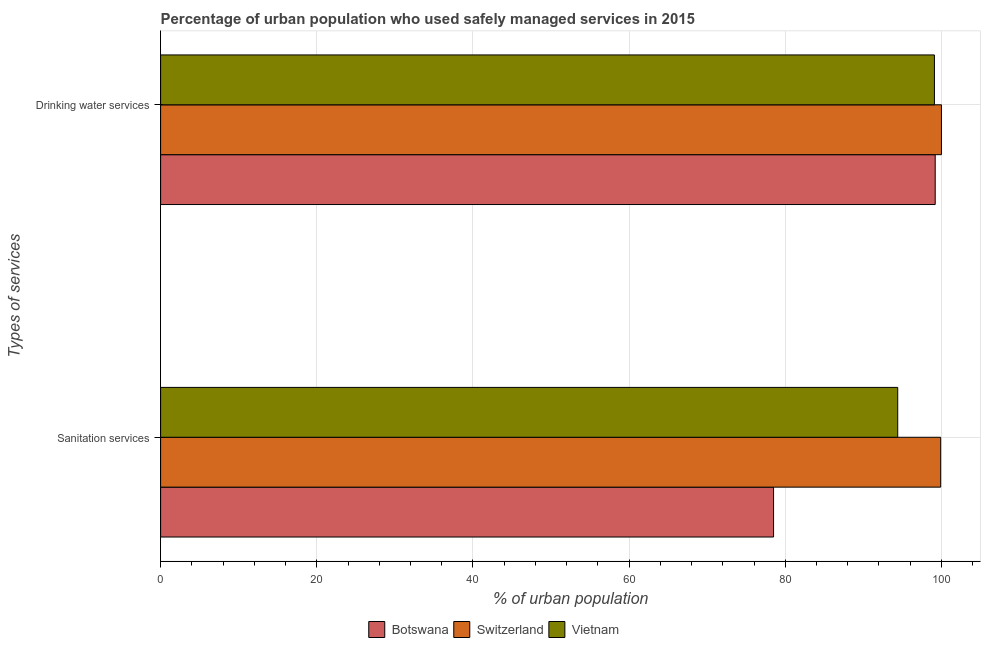How many different coloured bars are there?
Provide a succinct answer. 3. Are the number of bars per tick equal to the number of legend labels?
Offer a terse response. Yes. Are the number of bars on each tick of the Y-axis equal?
Provide a short and direct response. Yes. How many bars are there on the 1st tick from the top?
Provide a short and direct response. 3. What is the label of the 2nd group of bars from the top?
Offer a terse response. Sanitation services. What is the percentage of urban population who used drinking water services in Botswana?
Your answer should be compact. 99.2. Across all countries, what is the maximum percentage of urban population who used drinking water services?
Keep it short and to the point. 100. Across all countries, what is the minimum percentage of urban population who used sanitation services?
Provide a short and direct response. 78.5. In which country was the percentage of urban population who used drinking water services maximum?
Provide a short and direct response. Switzerland. In which country was the percentage of urban population who used sanitation services minimum?
Give a very brief answer. Botswana. What is the total percentage of urban population who used drinking water services in the graph?
Provide a short and direct response. 298.3. What is the difference between the percentage of urban population who used drinking water services in Switzerland and that in Vietnam?
Provide a succinct answer. 0.9. What is the difference between the percentage of urban population who used drinking water services in Vietnam and the percentage of urban population who used sanitation services in Botswana?
Your answer should be very brief. 20.6. What is the average percentage of urban population who used drinking water services per country?
Your response must be concise. 99.43. What is the difference between the percentage of urban population who used drinking water services and percentage of urban population who used sanitation services in Botswana?
Offer a very short reply. 20.7. What is the ratio of the percentage of urban population who used sanitation services in Switzerland to that in Botswana?
Ensure brevity in your answer.  1.27. Is the percentage of urban population who used drinking water services in Botswana less than that in Vietnam?
Provide a succinct answer. No. What does the 3rd bar from the top in Drinking water services represents?
Make the answer very short. Botswana. What does the 3rd bar from the bottom in Sanitation services represents?
Make the answer very short. Vietnam. What is the difference between two consecutive major ticks on the X-axis?
Provide a succinct answer. 20. Are the values on the major ticks of X-axis written in scientific E-notation?
Your answer should be compact. No. Does the graph contain any zero values?
Make the answer very short. No. Does the graph contain grids?
Make the answer very short. Yes. Where does the legend appear in the graph?
Give a very brief answer. Bottom center. What is the title of the graph?
Keep it short and to the point. Percentage of urban population who used safely managed services in 2015. Does "Nepal" appear as one of the legend labels in the graph?
Provide a short and direct response. No. What is the label or title of the X-axis?
Your answer should be compact. % of urban population. What is the label or title of the Y-axis?
Your response must be concise. Types of services. What is the % of urban population in Botswana in Sanitation services?
Keep it short and to the point. 78.5. What is the % of urban population in Switzerland in Sanitation services?
Ensure brevity in your answer.  99.9. What is the % of urban population of Vietnam in Sanitation services?
Offer a terse response. 94.4. What is the % of urban population of Botswana in Drinking water services?
Your answer should be very brief. 99.2. What is the % of urban population of Switzerland in Drinking water services?
Your answer should be compact. 100. What is the % of urban population in Vietnam in Drinking water services?
Give a very brief answer. 99.1. Across all Types of services, what is the maximum % of urban population in Botswana?
Offer a very short reply. 99.2. Across all Types of services, what is the maximum % of urban population in Switzerland?
Provide a short and direct response. 100. Across all Types of services, what is the maximum % of urban population in Vietnam?
Your answer should be compact. 99.1. Across all Types of services, what is the minimum % of urban population in Botswana?
Give a very brief answer. 78.5. Across all Types of services, what is the minimum % of urban population of Switzerland?
Give a very brief answer. 99.9. Across all Types of services, what is the minimum % of urban population of Vietnam?
Your answer should be compact. 94.4. What is the total % of urban population in Botswana in the graph?
Offer a very short reply. 177.7. What is the total % of urban population of Switzerland in the graph?
Your answer should be very brief. 199.9. What is the total % of urban population of Vietnam in the graph?
Your answer should be very brief. 193.5. What is the difference between the % of urban population in Botswana in Sanitation services and that in Drinking water services?
Keep it short and to the point. -20.7. What is the difference between the % of urban population in Switzerland in Sanitation services and that in Drinking water services?
Give a very brief answer. -0.1. What is the difference between the % of urban population of Vietnam in Sanitation services and that in Drinking water services?
Your answer should be very brief. -4.7. What is the difference between the % of urban population in Botswana in Sanitation services and the % of urban population in Switzerland in Drinking water services?
Provide a short and direct response. -21.5. What is the difference between the % of urban population in Botswana in Sanitation services and the % of urban population in Vietnam in Drinking water services?
Ensure brevity in your answer.  -20.6. What is the difference between the % of urban population of Switzerland in Sanitation services and the % of urban population of Vietnam in Drinking water services?
Your response must be concise. 0.8. What is the average % of urban population of Botswana per Types of services?
Give a very brief answer. 88.85. What is the average % of urban population of Switzerland per Types of services?
Offer a terse response. 99.95. What is the average % of urban population of Vietnam per Types of services?
Your answer should be very brief. 96.75. What is the difference between the % of urban population of Botswana and % of urban population of Switzerland in Sanitation services?
Offer a very short reply. -21.4. What is the difference between the % of urban population in Botswana and % of urban population in Vietnam in Sanitation services?
Make the answer very short. -15.9. What is the difference between the % of urban population in Botswana and % of urban population in Vietnam in Drinking water services?
Offer a terse response. 0.1. What is the difference between the % of urban population of Switzerland and % of urban population of Vietnam in Drinking water services?
Ensure brevity in your answer.  0.9. What is the ratio of the % of urban population of Botswana in Sanitation services to that in Drinking water services?
Offer a very short reply. 0.79. What is the ratio of the % of urban population in Switzerland in Sanitation services to that in Drinking water services?
Your response must be concise. 1. What is the ratio of the % of urban population in Vietnam in Sanitation services to that in Drinking water services?
Provide a succinct answer. 0.95. What is the difference between the highest and the second highest % of urban population in Botswana?
Give a very brief answer. 20.7. What is the difference between the highest and the second highest % of urban population in Switzerland?
Offer a terse response. 0.1. What is the difference between the highest and the lowest % of urban population of Botswana?
Your answer should be compact. 20.7. What is the difference between the highest and the lowest % of urban population of Vietnam?
Your response must be concise. 4.7. 